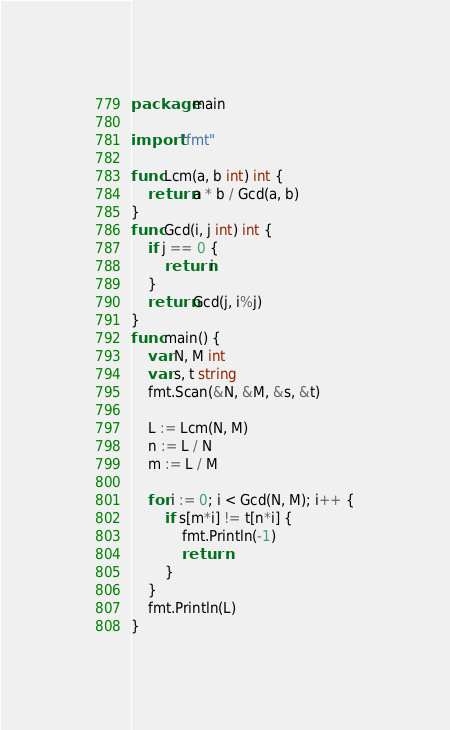Convert code to text. <code><loc_0><loc_0><loc_500><loc_500><_Go_>package main

import "fmt"

func Lcm(a, b int) int {
	return a * b / Gcd(a, b)
}
func Gcd(i, j int) int {
	if j == 0 {
		return i
	}
	return Gcd(j, i%j)
}
func main() {
	var N, M int
	var s, t string
	fmt.Scan(&N, &M, &s, &t)

	L := Lcm(N, M)
	n := L / N
	m := L / M

	for i := 0; i < Gcd(N, M); i++ {
		if s[m*i] != t[n*i] {
			fmt.Println(-1)
			return
		}
	}
	fmt.Println(L)
}
</code> 